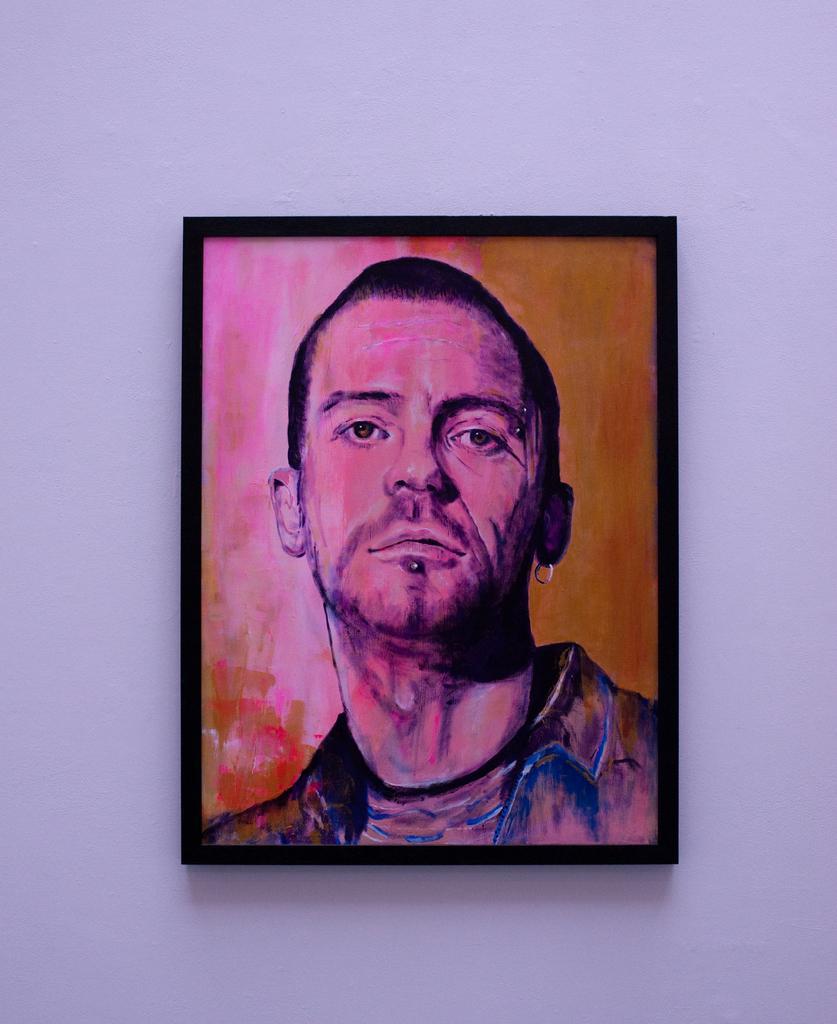How would you summarize this image in a sentence or two? In this picture there is a painting of a person on the frame. There is a frame on the wall. 